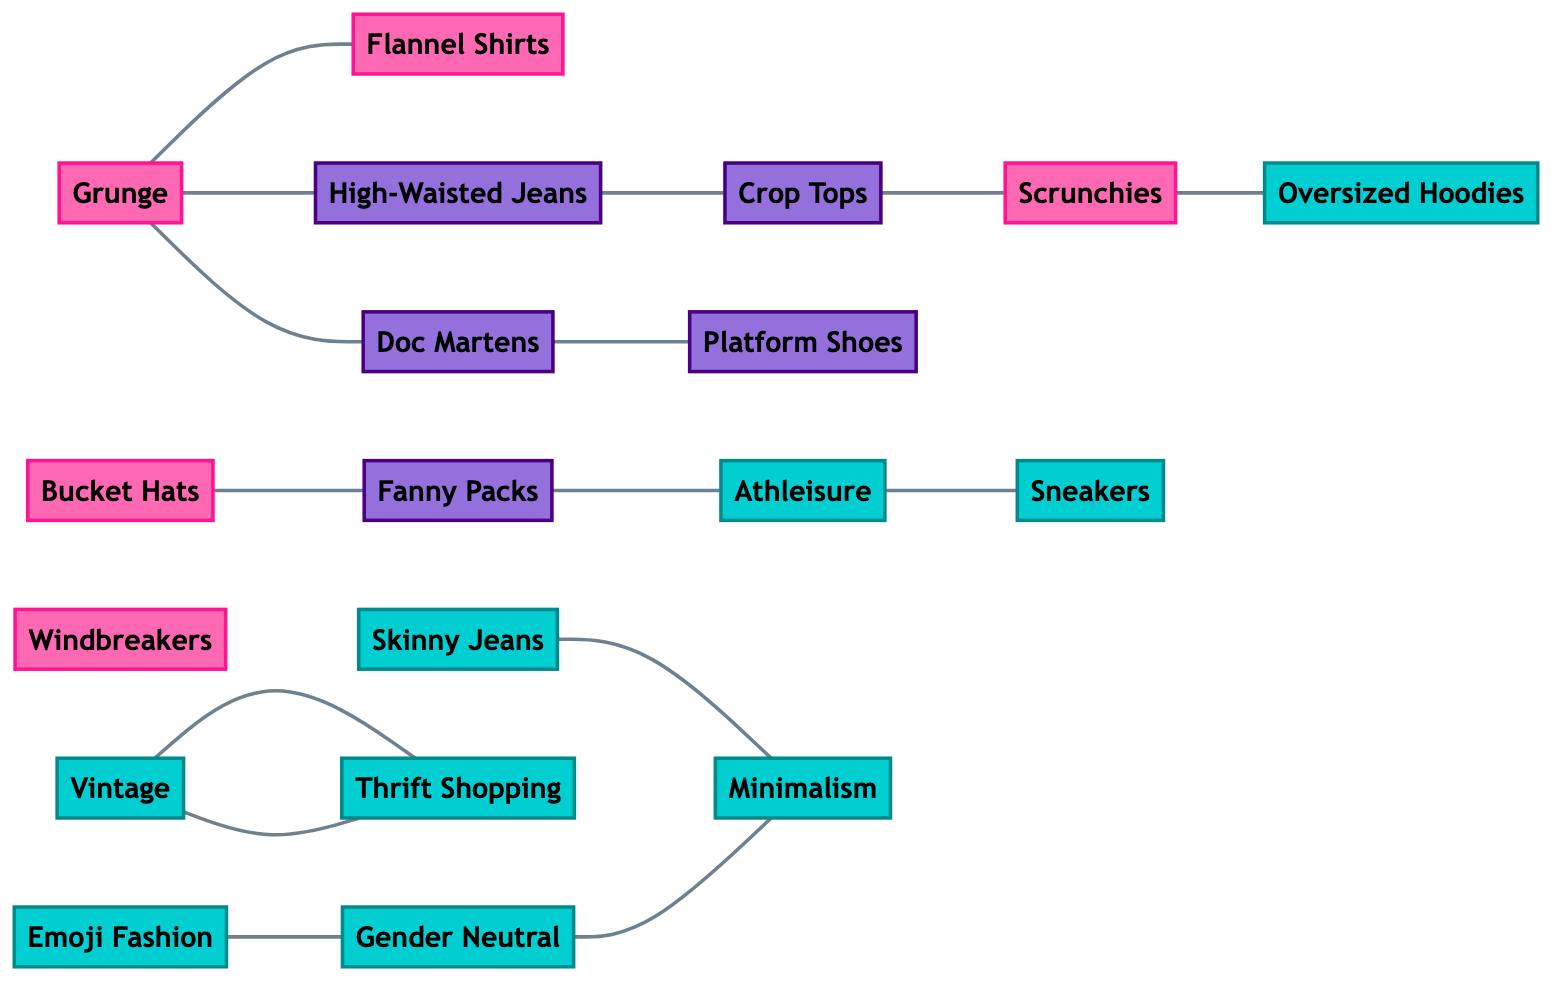What are the two main fashion trends from the 90s visually represented in the diagram? The diagram shows "Grunge" and "Bucket Hats" as key fashion trends from the 90s. "Grunge" is connected to "Doc Martens," "Flannel Shirts," and "High-Waisted Jeans," indicating its influence on these trends. "Bucket Hats," also from the 90s, is connected to "Fanny Packs."
Answer: Grunge, Bucket Hats How many edges are there in the diagram? To find the total number of edges, we count all connections (or edges) between nodes in the diagram. The diagram lists a total of 13 edges connecting the various nodes.
Answer: 13 Which modern fashion trend is connected to "Oversized Hoodies"? "Scrunchies," which is a 90s trend, connects to "Oversized Hoodies." In turn, "Scrunchies" connect back to other 90s themes and the modern trend indicates a transition rather than a direct connection.
Answer: Oversized Hoodies What shared element connects "Fanny Packs" and "Athleisure"? "Fanny Packs" is connected to "Athleisure" indicating they are linked through a shared style element. The direct connection shows that these two trends share a common influence.
Answer: Fanny Packs Which two nodes in the diagram represent the concept of vintage fashion? "Vintage" and "Thrift Shopping" nodes indicate the theme of vintage fashion. They are directly connected, illustrating the close relationship between the two in terms of trend sharing.
Answer: Vintage, Thrift Shopping What does the connection between "Gender Neutral" and "Minimalism" imply about modern fashion? The connection indicates that modern fashion is increasingly embracing gender-neutral styles while favoring minimalistic design. This illustrates a significant shift towards inclusivity and simplicity in contemporary trends.
Answer: Inclusivity and simplicity Which 90s trend is represented by "Doc Martens"? "Doc Martens" is a key representation of the 90s grunge trend, showcasing its uniqueness in style during that era. The diagram clearly links it to other 90s fashion trends, establishing its influence.
Answer: Grunge How many fashion trends specifically belong to the modern category? By examining the diagram, we identify that there are 6 trends categorized strictly under modern fashion. They are "Athleisure," "Skinny Jeans," "Sneakers," "Oversized Hoodies," "Vintage," and "Minimalism."
Answer: 6 What is the main connection between "Crop Tops" and "High-Waisted Jeans"? The two nodes are directly connected, which signifies that "Crop Tops" typically pair well with "High-Waisted Jeans," illustrating a popular fashion combination of the era.
Answer: Pairing 